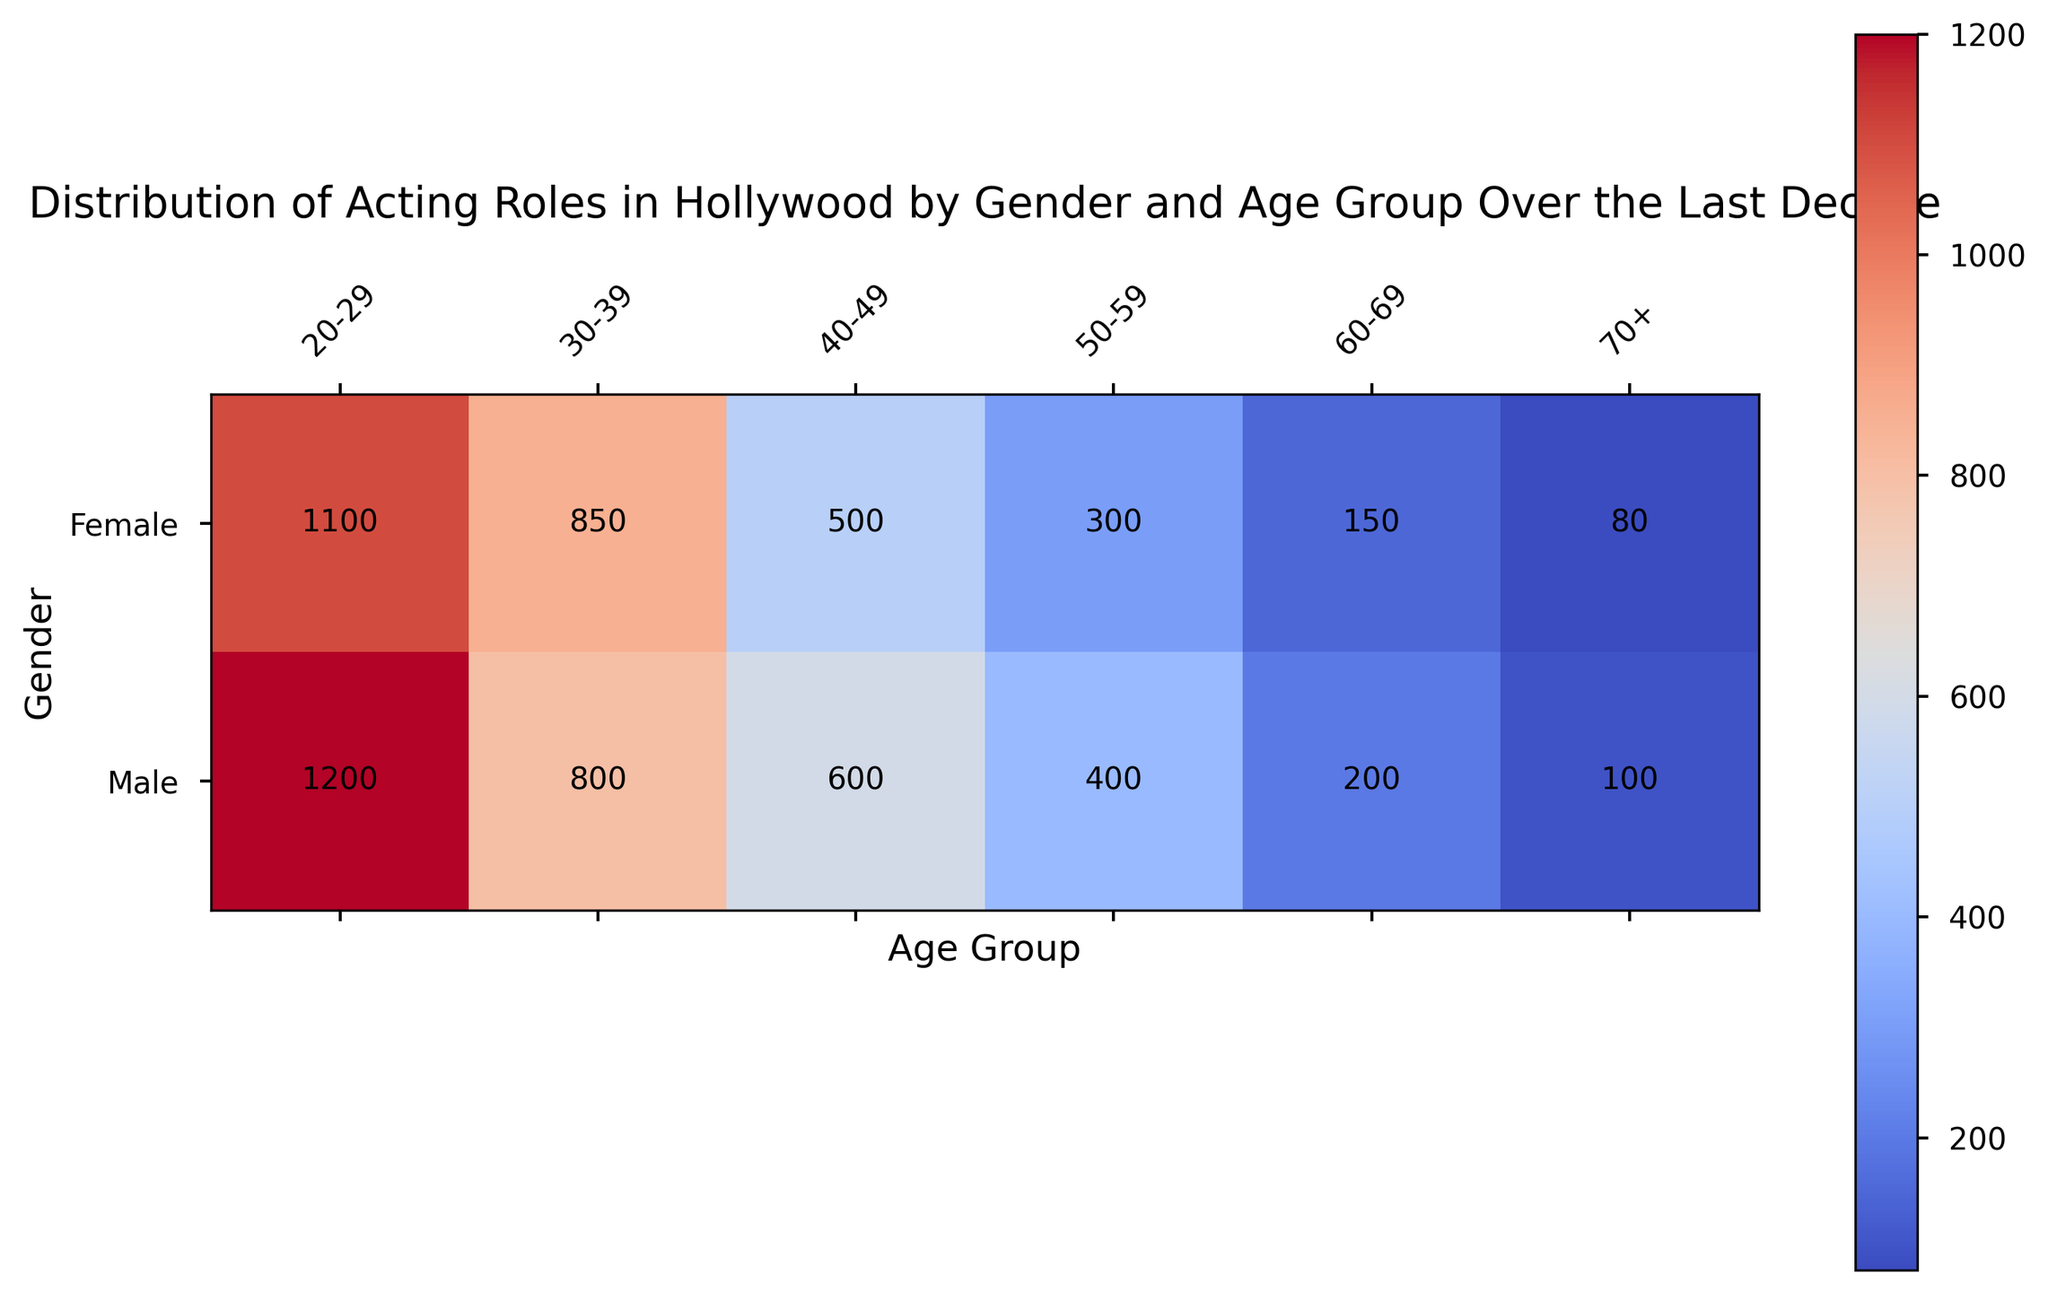Which age group has the least difference in the number of roles between genders? To find the age group with the least difference, subtract the number of roles for females from that of males for each age group:  
20-29: 1200 - 1100 = 100  
30-39: 800 - 850 = -50  
40-49: 600 - 500 = 100  
50-59: 400 - 300 = 100  
60-69: 200 - 150 = 50  
70+: 100 - 80 = 20  
The smallest absolute difference is 20 for the age group 70+.
Answer: 70+ Which gender has the most acting roles in the 30-39 age group? Look at the values for the 30-39 age group: 800 for males and 850 for females. The higher number is for females.
Answer: Female In which age group do males have the highest number of roles? Check the number of roles across age groups for males:  
20-29: 1200  
30-39: 800  
40-49: 600  
50-59: 400  
60-69: 200  
70+: 100  
The highest number is in the age group 20-29 with 1200 roles.
Answer: 20-29 What is the total number of roles for females across all age groups? Sum the roles for females across all age groups:  
1100 (20-29) + 850 (30-39) + 500 (40-49) + 300 (50-59) + 150 (60-69) + 80 (70+) = 2980 roles.
Answer: 2980 Which age group shows the largest discrepancy between males and females in terms of acting roles? Subtract the number of roles for females from that of males for each age group and find the largest absolute value:  
20-29: 100  
30-39: -50  
40-49: 100  
50-59: 100  
60-69: 50  
70+: 20  
The largest discrepancy is 100 for the age groups 20-29, 40-49, and 50-59.
Answer: 20-29, 40-49, 50-59 How does the number of roles for females change as age increases from 20-29 to 30-39? Compare the number of roles for females in the 20-29 and 30-39 age groups.  
20-29: 1100  
30-39: 850  
There is a decrease of 1100 - 850 = 250 roles.
Answer: Decreases by 250 What is the average number of acting roles for males in the age groups 40-49 and 50-59? Add the number of roles in both age groups and divide by 2:  
(600 (40-49) + 400 (50-59)) / 2 = 1000 / 2 = 500 roles.
Answer: 500 What is the overall trend in the distribution of acting roles for males as age increases? Observe the values for males across increasing age groups:  
20-29: 1200  
30-39: 800  
40-49: 600  
50-59: 400  
60-69: 200  
70+: 100  
The trend shows a decrease in the number of acting roles for males as age increases.
Answer: Decreasing 